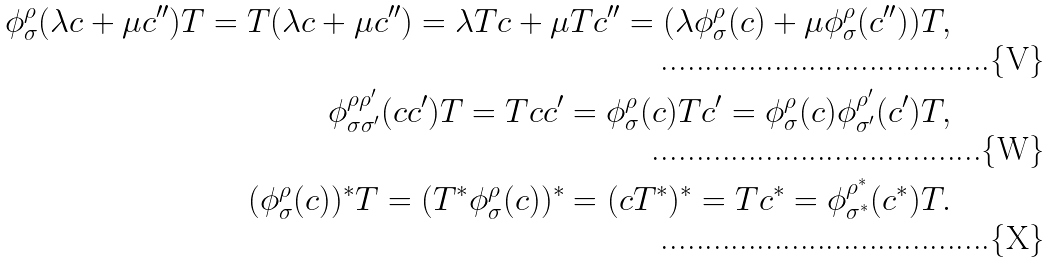Convert formula to latex. <formula><loc_0><loc_0><loc_500><loc_500>\phi ^ { \rho } _ { \sigma } ( \lambda c + \mu c ^ { \prime \prime } ) T = T ( \lambda c + \mu c ^ { \prime \prime } ) = \lambda T c + \mu T c ^ { \prime \prime } = ( \lambda \phi ^ { \rho } _ { \sigma } ( c ) + \mu \phi ^ { \rho } _ { \sigma } ( c ^ { \prime \prime } ) ) T , \\ \phi ^ { \rho \rho ^ { \prime } } _ { \sigma \sigma ^ { \prime } } ( c c ^ { \prime } ) T = T c c ^ { \prime } = \phi ^ { \rho } _ { \sigma } ( c ) T c ^ { \prime } = \phi ^ { \rho } _ { \sigma } ( c ) \phi ^ { \rho ^ { \prime } } _ { \sigma ^ { \prime } } ( c ^ { \prime } ) T , \\ ( \phi ^ { \rho } _ { \sigma } ( c ) ) ^ { * } T = ( T ^ { * } \phi ^ { \rho } _ { \sigma } ( c ) ) ^ { * } = ( c T ^ { * } ) ^ { * } = T c ^ { * } = \phi ^ { \rho ^ { * } } _ { \sigma ^ { * } } ( c ^ { * } ) T .</formula> 